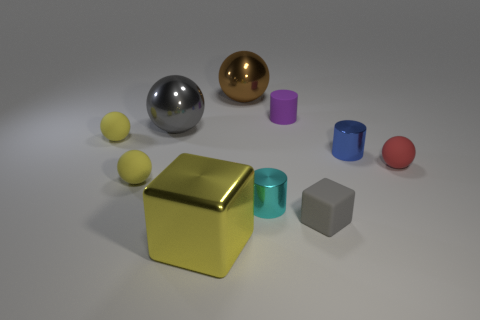Subtract all gray spheres. How many spheres are left? 4 Subtract all purple cylinders. How many cylinders are left? 2 Subtract 2 cylinders. How many cylinders are left? 1 Subtract all cubes. How many objects are left? 8 Add 2 large yellow shiny blocks. How many large yellow shiny blocks exist? 3 Subtract 0 cyan blocks. How many objects are left? 10 Subtract all yellow spheres. Subtract all green cylinders. How many spheres are left? 3 Subtract all cyan blocks. How many purple cylinders are left? 1 Subtract all small cyan cylinders. Subtract all purple cylinders. How many objects are left? 8 Add 5 small yellow matte spheres. How many small yellow matte spheres are left? 7 